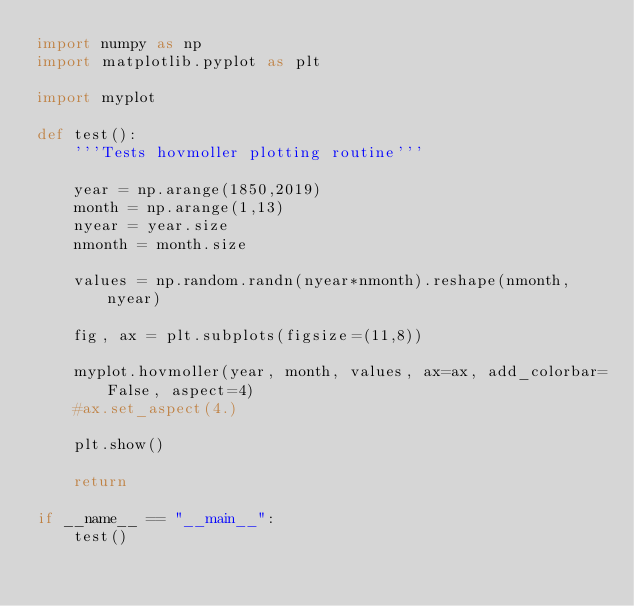Convert code to text. <code><loc_0><loc_0><loc_500><loc_500><_Python_>import numpy as np
import matplotlib.pyplot as plt

import myplot

def test():
    '''Tests hovmoller plotting routine'''
    
    year = np.arange(1850,2019)
    month = np.arange(1,13)
    nyear = year.size
    nmonth = month.size
    
    values = np.random.randn(nyear*nmonth).reshape(nmonth, nyear)

    fig, ax = plt.subplots(figsize=(11,8))

    myplot.hovmoller(year, month, values, ax=ax, add_colorbar=False, aspect=4)
    #ax.set_aspect(4.)
    
    plt.show()
    
    return

if __name__ == "__main__":
    test()
</code> 